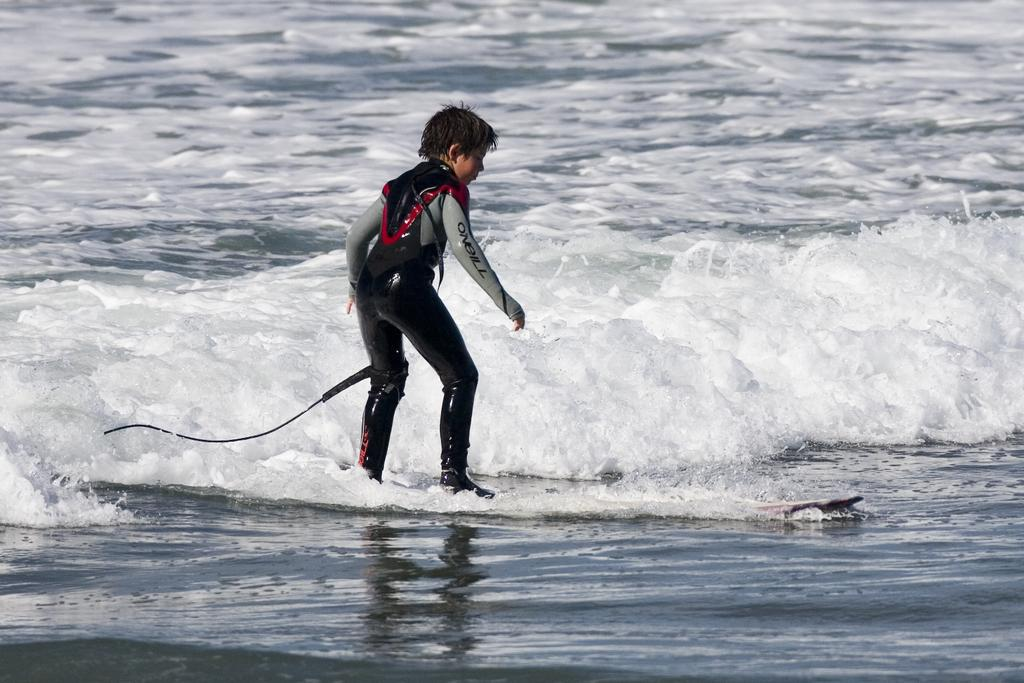<image>
Relay a brief, clear account of the picture shown. A child in an O'neill wetsuit is surfing a wave. 